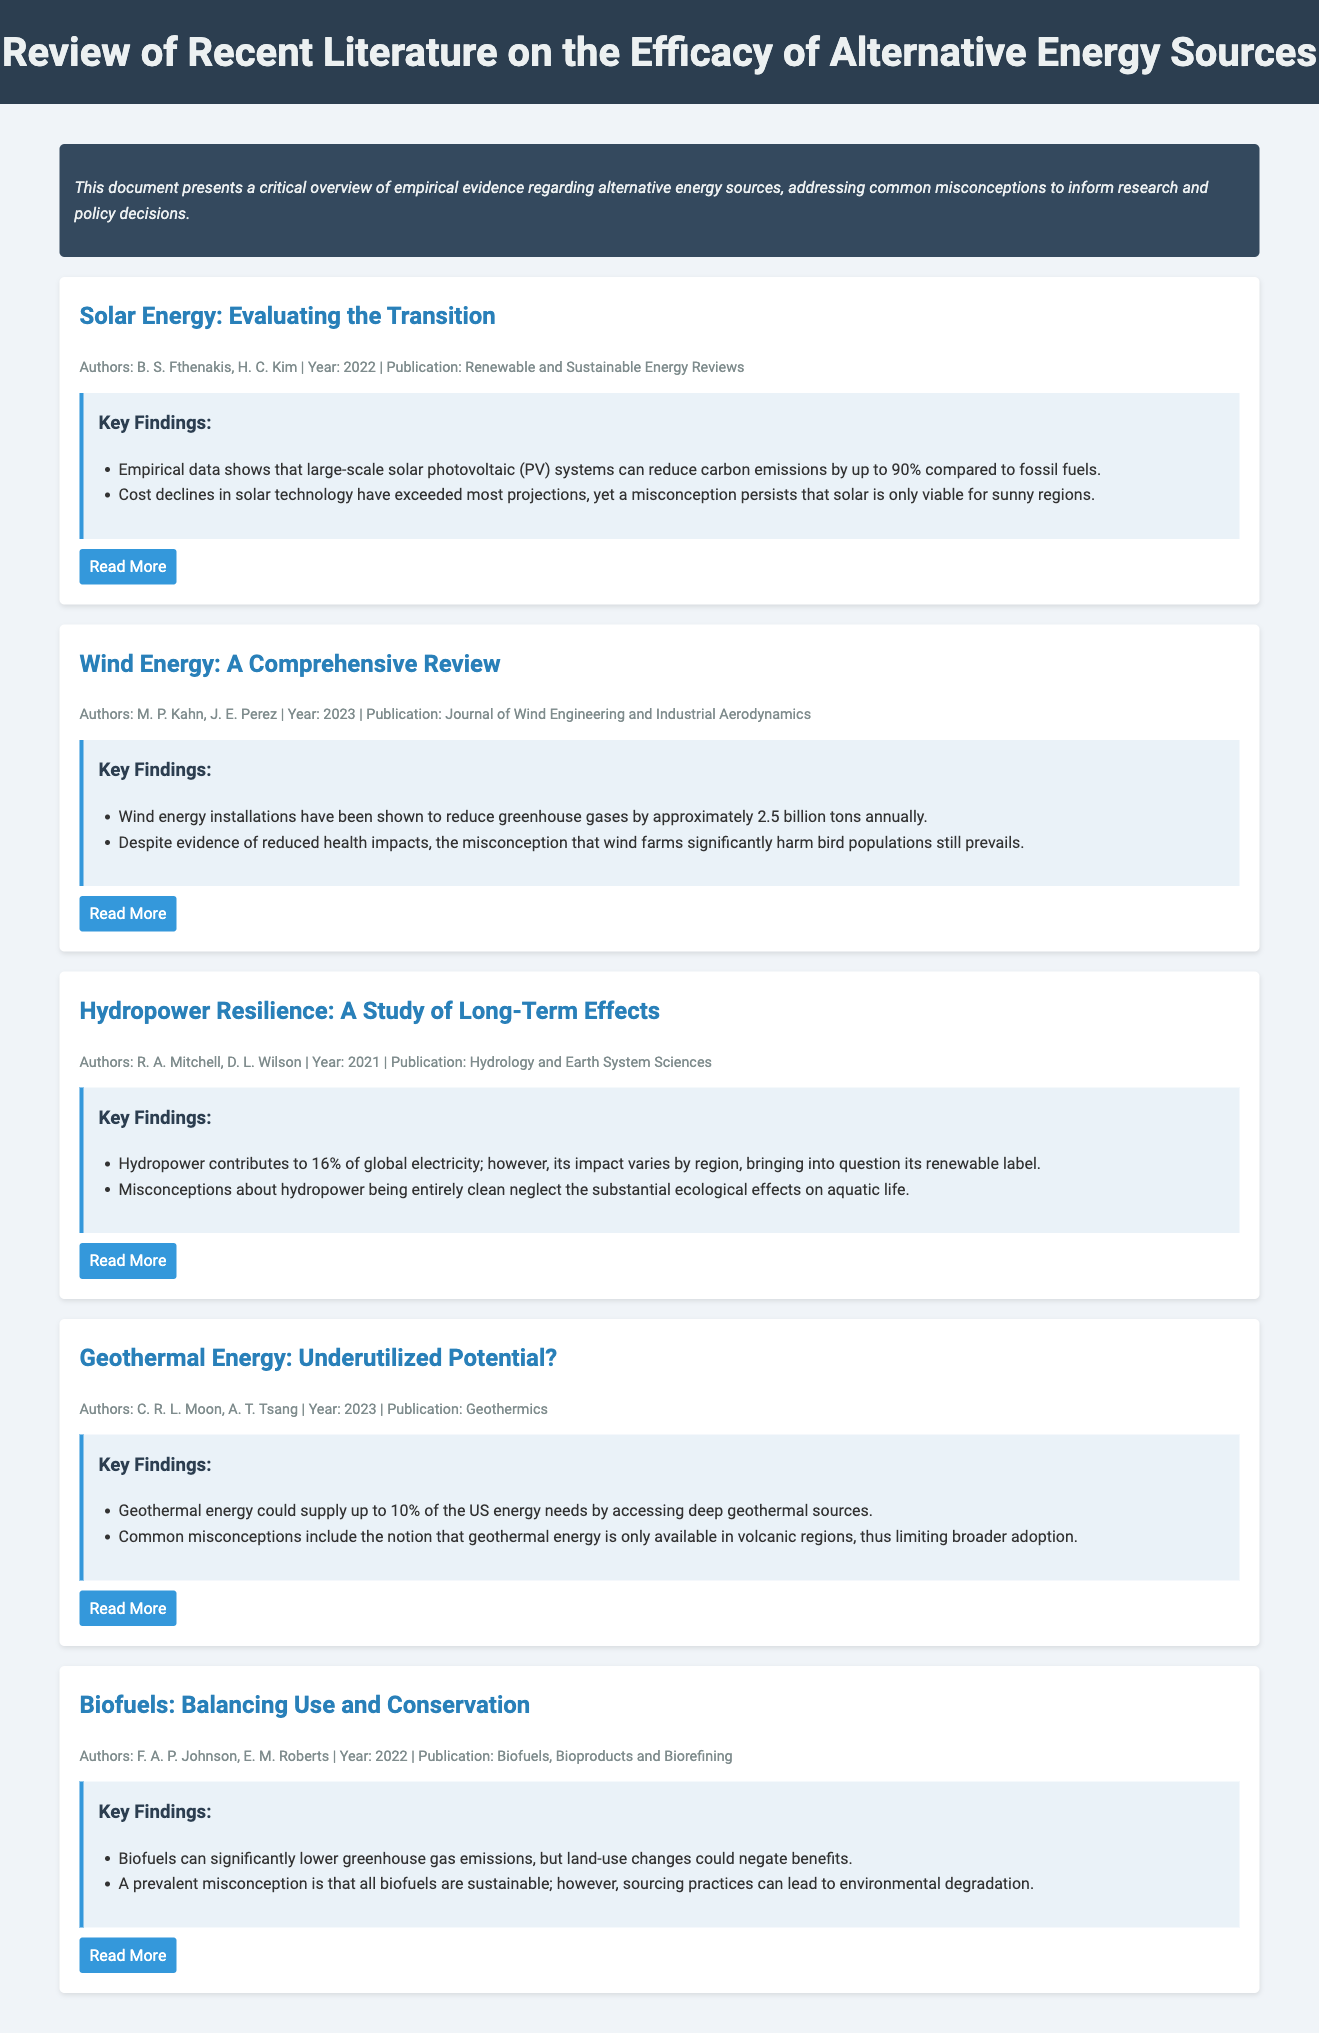What is the title of the document? The title is located in the header of the document.
Answer: Review of Recent Literature on the Efficacy of Alternative Energy Sources Who are the authors of the wind energy review? The authors are listed in the metadata of the specific material section.
Answer: M. P. Kahn, J. E. Perez In which year was the solar energy review published? The publication year is provided in the metadata for each material section.
Answer: 2022 What percentage of global electricity does hydropower contribute? This information is found in the key findings for the hydropower section.
Answer: 16% Which energy source claims a potential supply of 10% of US energy needs? This question refers to the specific claims made in the geothermal section of the document.
Answer: Geothermal energy What misconception is associated with biofuels? The misconceptions are presented in the key findings of the biofuels section.
Answer: All biofuels are sustainable What is the main ecological effect noted for hydropower? This information is detailed in the key findings of the hydropower study.
Answer: Substantial ecological effects on aquatic life How much greenhouse gas do wind energy installations reduce annually? This figure is specified in the key findings for wind energy.
Answer: Approximately 2.5 billion tons What was the main focus of the document summary? The summary indicates the primary aim of the document regarding alternative energy sources.
Answer: Empirical evidence and common misconceptions 